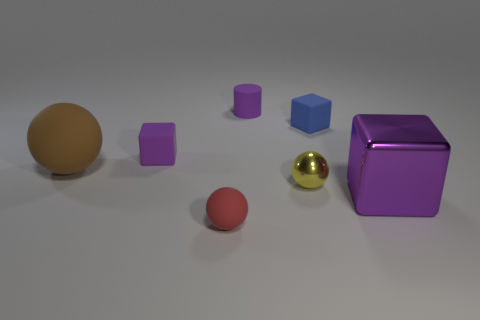Add 2 metallic things. How many objects exist? 9 Subtract all cylinders. How many objects are left? 6 Subtract all yellow things. Subtract all tiny matte balls. How many objects are left? 5 Add 5 blue rubber cubes. How many blue rubber cubes are left? 6 Add 7 big red spheres. How many big red spheres exist? 7 Subtract 0 red cubes. How many objects are left? 7 